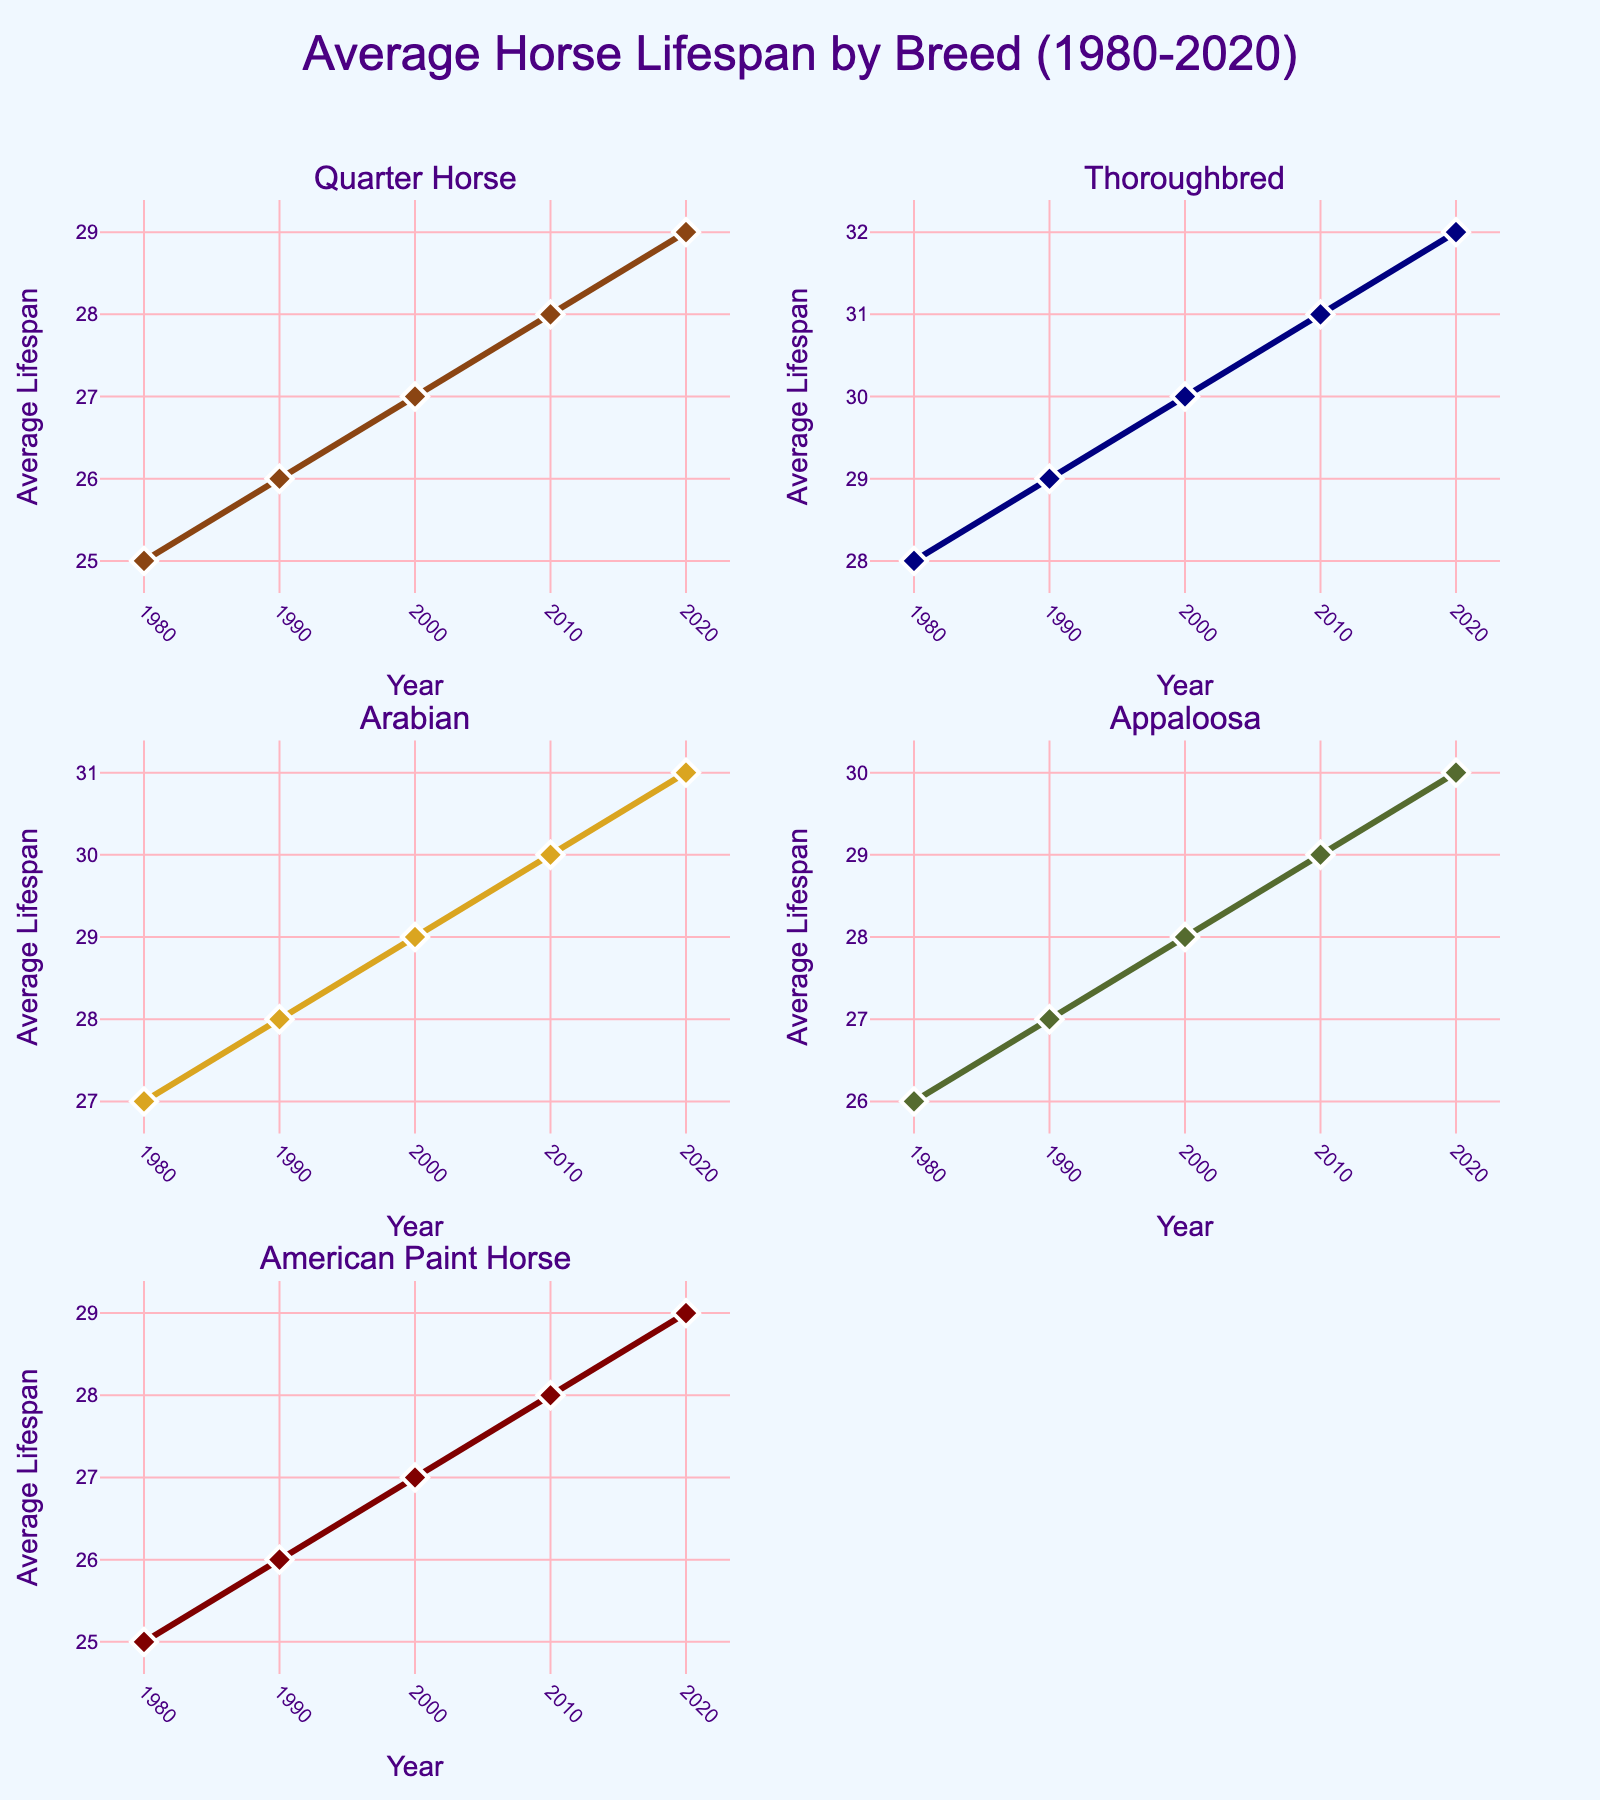What is the title of the figure? The title is typically found at the top of the figure and provides an overview of what the chart is about. In this case, it covers the average horse lifespan by breed over a period of time.
Answer: Average Horse Lifespan by Breed (1980-2020) Which breed has the highest average lifespan in 2020? By comparing the data points for 2020 across all subplots, we see that the Thoroughbred has the highest average lifespan.
Answer: Thoroughbred How does the lifespan of the Arabian breed change from 1980 to 2020? Observing the trend line in the Arabian subplot, the lifespan increases consistently from 27 years in 1980 to 31 years in 2020.
Answer: It increases Which breed shows the smallest increase in average lifespan from 1980 to 2020? By comparing the differences from 1980 to 2020 for all breeds, we find that Quarter Horse has the smallest increase from 25 to 29 years, a total increase of 4 years.
Answer: Quarter Horse What is the average lifespan of the Appaloosa breed in the 2000s? The lifespan values for 2000 and 2010 are considered since they are in the 2000s. Taking the average of 28 and 29, we get (28 + 29) / 2 = 28.5 years.
Answer: 28.5 years How many years does it take for the Thoroughbred breed to reach an average lifespan of 30 years? Observing the Thoroughbred subplot, it reaches an average lifespan of 30 years in the year 2000. Starting from 1980, it takes 20 years.
Answer: 20 years Which breed had a consistent increase in average lifespan every decade? By examining each subplot, both Thoroughbred and Arabian breeds show a consistent increase in lifespan every decade from 1980 to 2020.
Answer: Thoroughbred, Arabian What can be inferred about the health improvements across breeds over time? Since all breeds show an increase in average lifespan from 1980 to 2020, it infers there have been health improvements or better care practices over time.
Answer: Health improvements are evident Which breed appears to have had the most stable lifespan trend? The Quarter Horse shows a smoother, less steep trend compared to others, indicating a more stable increase over time.
Answer: Quarter Horse 